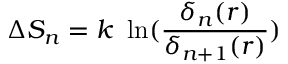<formula> <loc_0><loc_0><loc_500><loc_500>\Delta S _ { n } = k \ \ln ( { \frac { \delta _ { n } ( r ) } { \delta _ { n + 1 } ( r ) } } )</formula> 